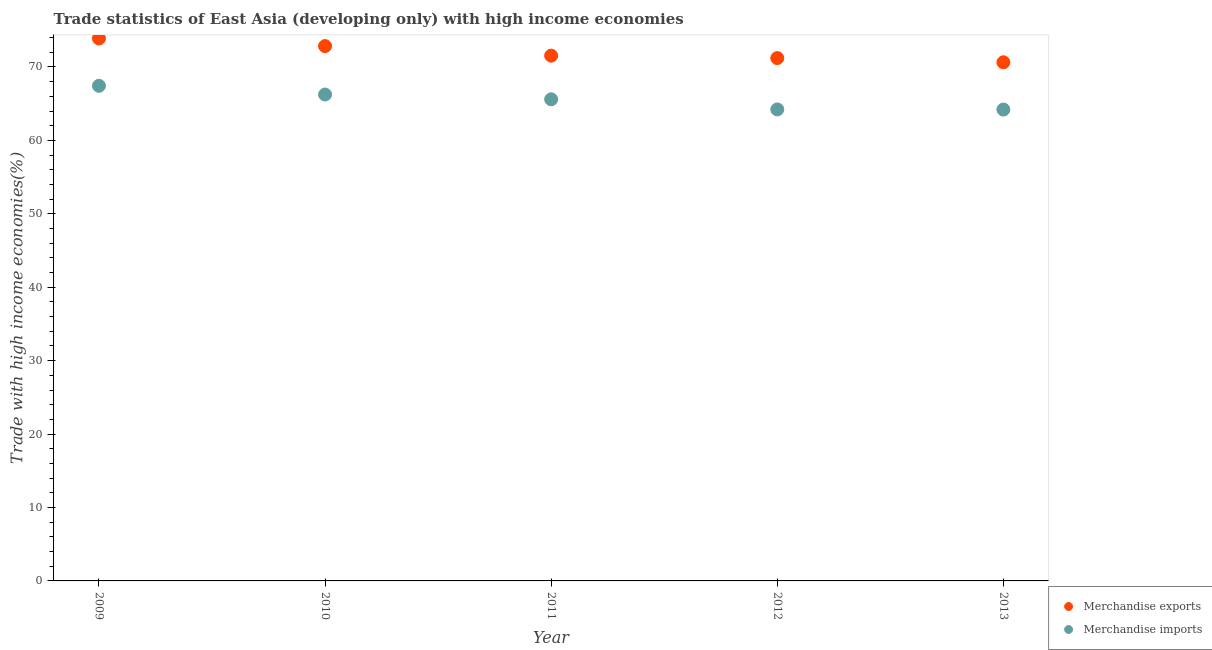Is the number of dotlines equal to the number of legend labels?
Provide a succinct answer. Yes. What is the merchandise imports in 2009?
Your answer should be very brief. 67.43. Across all years, what is the maximum merchandise imports?
Your answer should be very brief. 67.43. Across all years, what is the minimum merchandise imports?
Offer a terse response. 64.2. In which year was the merchandise exports maximum?
Your answer should be very brief. 2009. What is the total merchandise imports in the graph?
Make the answer very short. 327.69. What is the difference between the merchandise exports in 2009 and that in 2010?
Provide a succinct answer. 1.04. What is the difference between the merchandise exports in 2010 and the merchandise imports in 2009?
Keep it short and to the point. 5.41. What is the average merchandise imports per year?
Your answer should be very brief. 65.54. In the year 2012, what is the difference between the merchandise exports and merchandise imports?
Give a very brief answer. 6.99. In how many years, is the merchandise imports greater than 72 %?
Your response must be concise. 0. What is the ratio of the merchandise imports in 2010 to that in 2013?
Make the answer very short. 1.03. Is the merchandise imports in 2011 less than that in 2012?
Give a very brief answer. No. Is the difference between the merchandise exports in 2011 and 2012 greater than the difference between the merchandise imports in 2011 and 2012?
Offer a very short reply. No. What is the difference between the highest and the second highest merchandise exports?
Keep it short and to the point. 1.04. What is the difference between the highest and the lowest merchandise exports?
Your answer should be compact. 3.25. In how many years, is the merchandise exports greater than the average merchandise exports taken over all years?
Keep it short and to the point. 2. How many dotlines are there?
Your answer should be very brief. 2. How many years are there in the graph?
Your answer should be compact. 5. What is the difference between two consecutive major ticks on the Y-axis?
Your response must be concise. 10. Does the graph contain any zero values?
Offer a terse response. No. Does the graph contain grids?
Offer a terse response. No. How many legend labels are there?
Your response must be concise. 2. How are the legend labels stacked?
Your answer should be very brief. Vertical. What is the title of the graph?
Your response must be concise. Trade statistics of East Asia (developing only) with high income economies. Does "National Tourists" appear as one of the legend labels in the graph?
Provide a short and direct response. No. What is the label or title of the Y-axis?
Your answer should be very brief. Trade with high income economies(%). What is the Trade with high income economies(%) in Merchandise exports in 2009?
Offer a very short reply. 73.89. What is the Trade with high income economies(%) of Merchandise imports in 2009?
Offer a very short reply. 67.43. What is the Trade with high income economies(%) in Merchandise exports in 2010?
Give a very brief answer. 72.84. What is the Trade with high income economies(%) in Merchandise imports in 2010?
Ensure brevity in your answer.  66.25. What is the Trade with high income economies(%) of Merchandise exports in 2011?
Offer a very short reply. 71.54. What is the Trade with high income economies(%) of Merchandise imports in 2011?
Provide a short and direct response. 65.6. What is the Trade with high income economies(%) of Merchandise exports in 2012?
Offer a terse response. 71.21. What is the Trade with high income economies(%) of Merchandise imports in 2012?
Ensure brevity in your answer.  64.22. What is the Trade with high income economies(%) of Merchandise exports in 2013?
Provide a short and direct response. 70.64. What is the Trade with high income economies(%) in Merchandise imports in 2013?
Provide a short and direct response. 64.2. Across all years, what is the maximum Trade with high income economies(%) of Merchandise exports?
Ensure brevity in your answer.  73.89. Across all years, what is the maximum Trade with high income economies(%) in Merchandise imports?
Your answer should be very brief. 67.43. Across all years, what is the minimum Trade with high income economies(%) in Merchandise exports?
Offer a very short reply. 70.64. Across all years, what is the minimum Trade with high income economies(%) of Merchandise imports?
Provide a succinct answer. 64.2. What is the total Trade with high income economies(%) of Merchandise exports in the graph?
Offer a very short reply. 360.12. What is the total Trade with high income economies(%) in Merchandise imports in the graph?
Provide a short and direct response. 327.69. What is the difference between the Trade with high income economies(%) of Merchandise exports in 2009 and that in 2010?
Your answer should be compact. 1.04. What is the difference between the Trade with high income economies(%) of Merchandise imports in 2009 and that in 2010?
Your answer should be very brief. 1.19. What is the difference between the Trade with high income economies(%) of Merchandise exports in 2009 and that in 2011?
Ensure brevity in your answer.  2.35. What is the difference between the Trade with high income economies(%) in Merchandise imports in 2009 and that in 2011?
Your answer should be compact. 1.84. What is the difference between the Trade with high income economies(%) in Merchandise exports in 2009 and that in 2012?
Give a very brief answer. 2.68. What is the difference between the Trade with high income economies(%) of Merchandise imports in 2009 and that in 2012?
Offer a very short reply. 3.22. What is the difference between the Trade with high income economies(%) of Merchandise exports in 2009 and that in 2013?
Your answer should be compact. 3.25. What is the difference between the Trade with high income economies(%) in Merchandise imports in 2009 and that in 2013?
Provide a succinct answer. 3.24. What is the difference between the Trade with high income economies(%) in Merchandise exports in 2010 and that in 2011?
Keep it short and to the point. 1.3. What is the difference between the Trade with high income economies(%) in Merchandise imports in 2010 and that in 2011?
Your answer should be very brief. 0.65. What is the difference between the Trade with high income economies(%) in Merchandise exports in 2010 and that in 2012?
Provide a succinct answer. 1.63. What is the difference between the Trade with high income economies(%) of Merchandise imports in 2010 and that in 2012?
Make the answer very short. 2.03. What is the difference between the Trade with high income economies(%) of Merchandise exports in 2010 and that in 2013?
Offer a terse response. 2.21. What is the difference between the Trade with high income economies(%) in Merchandise imports in 2010 and that in 2013?
Offer a terse response. 2.05. What is the difference between the Trade with high income economies(%) in Merchandise exports in 2011 and that in 2012?
Your answer should be very brief. 0.33. What is the difference between the Trade with high income economies(%) in Merchandise imports in 2011 and that in 2012?
Your answer should be very brief. 1.38. What is the difference between the Trade with high income economies(%) in Merchandise exports in 2011 and that in 2013?
Offer a terse response. 0.9. What is the difference between the Trade with high income economies(%) of Merchandise imports in 2011 and that in 2013?
Your answer should be compact. 1.4. What is the difference between the Trade with high income economies(%) in Merchandise exports in 2012 and that in 2013?
Make the answer very short. 0.57. What is the difference between the Trade with high income economies(%) in Merchandise imports in 2012 and that in 2013?
Your answer should be compact. 0.02. What is the difference between the Trade with high income economies(%) of Merchandise exports in 2009 and the Trade with high income economies(%) of Merchandise imports in 2010?
Ensure brevity in your answer.  7.64. What is the difference between the Trade with high income economies(%) of Merchandise exports in 2009 and the Trade with high income economies(%) of Merchandise imports in 2011?
Give a very brief answer. 8.29. What is the difference between the Trade with high income economies(%) in Merchandise exports in 2009 and the Trade with high income economies(%) in Merchandise imports in 2012?
Provide a succinct answer. 9.67. What is the difference between the Trade with high income economies(%) in Merchandise exports in 2009 and the Trade with high income economies(%) in Merchandise imports in 2013?
Your response must be concise. 9.69. What is the difference between the Trade with high income economies(%) of Merchandise exports in 2010 and the Trade with high income economies(%) of Merchandise imports in 2011?
Your response must be concise. 7.25. What is the difference between the Trade with high income economies(%) of Merchandise exports in 2010 and the Trade with high income economies(%) of Merchandise imports in 2012?
Offer a very short reply. 8.63. What is the difference between the Trade with high income economies(%) in Merchandise exports in 2010 and the Trade with high income economies(%) in Merchandise imports in 2013?
Keep it short and to the point. 8.65. What is the difference between the Trade with high income economies(%) of Merchandise exports in 2011 and the Trade with high income economies(%) of Merchandise imports in 2012?
Your response must be concise. 7.32. What is the difference between the Trade with high income economies(%) in Merchandise exports in 2011 and the Trade with high income economies(%) in Merchandise imports in 2013?
Give a very brief answer. 7.34. What is the difference between the Trade with high income economies(%) of Merchandise exports in 2012 and the Trade with high income economies(%) of Merchandise imports in 2013?
Give a very brief answer. 7.01. What is the average Trade with high income economies(%) in Merchandise exports per year?
Keep it short and to the point. 72.02. What is the average Trade with high income economies(%) in Merchandise imports per year?
Offer a very short reply. 65.54. In the year 2009, what is the difference between the Trade with high income economies(%) of Merchandise exports and Trade with high income economies(%) of Merchandise imports?
Your answer should be compact. 6.45. In the year 2010, what is the difference between the Trade with high income economies(%) of Merchandise exports and Trade with high income economies(%) of Merchandise imports?
Offer a very short reply. 6.6. In the year 2011, what is the difference between the Trade with high income economies(%) of Merchandise exports and Trade with high income economies(%) of Merchandise imports?
Your answer should be very brief. 5.95. In the year 2012, what is the difference between the Trade with high income economies(%) of Merchandise exports and Trade with high income economies(%) of Merchandise imports?
Offer a terse response. 6.99. In the year 2013, what is the difference between the Trade with high income economies(%) in Merchandise exports and Trade with high income economies(%) in Merchandise imports?
Make the answer very short. 6.44. What is the ratio of the Trade with high income economies(%) in Merchandise exports in 2009 to that in 2010?
Your response must be concise. 1.01. What is the ratio of the Trade with high income economies(%) of Merchandise imports in 2009 to that in 2010?
Offer a terse response. 1.02. What is the ratio of the Trade with high income economies(%) in Merchandise exports in 2009 to that in 2011?
Your answer should be very brief. 1.03. What is the ratio of the Trade with high income economies(%) in Merchandise imports in 2009 to that in 2011?
Your response must be concise. 1.03. What is the ratio of the Trade with high income economies(%) in Merchandise exports in 2009 to that in 2012?
Provide a succinct answer. 1.04. What is the ratio of the Trade with high income economies(%) in Merchandise imports in 2009 to that in 2012?
Provide a succinct answer. 1.05. What is the ratio of the Trade with high income economies(%) in Merchandise exports in 2009 to that in 2013?
Your answer should be very brief. 1.05. What is the ratio of the Trade with high income economies(%) in Merchandise imports in 2009 to that in 2013?
Provide a short and direct response. 1.05. What is the ratio of the Trade with high income economies(%) of Merchandise exports in 2010 to that in 2011?
Ensure brevity in your answer.  1.02. What is the ratio of the Trade with high income economies(%) of Merchandise imports in 2010 to that in 2011?
Make the answer very short. 1.01. What is the ratio of the Trade with high income economies(%) of Merchandise exports in 2010 to that in 2012?
Offer a very short reply. 1.02. What is the ratio of the Trade with high income economies(%) in Merchandise imports in 2010 to that in 2012?
Your answer should be compact. 1.03. What is the ratio of the Trade with high income economies(%) in Merchandise exports in 2010 to that in 2013?
Offer a very short reply. 1.03. What is the ratio of the Trade with high income economies(%) of Merchandise imports in 2010 to that in 2013?
Your response must be concise. 1.03. What is the ratio of the Trade with high income economies(%) in Merchandise imports in 2011 to that in 2012?
Provide a succinct answer. 1.02. What is the ratio of the Trade with high income economies(%) of Merchandise exports in 2011 to that in 2013?
Keep it short and to the point. 1.01. What is the ratio of the Trade with high income economies(%) of Merchandise imports in 2011 to that in 2013?
Your response must be concise. 1.02. What is the difference between the highest and the second highest Trade with high income economies(%) in Merchandise exports?
Your answer should be compact. 1.04. What is the difference between the highest and the second highest Trade with high income economies(%) in Merchandise imports?
Provide a short and direct response. 1.19. What is the difference between the highest and the lowest Trade with high income economies(%) in Merchandise exports?
Provide a short and direct response. 3.25. What is the difference between the highest and the lowest Trade with high income economies(%) in Merchandise imports?
Give a very brief answer. 3.24. 